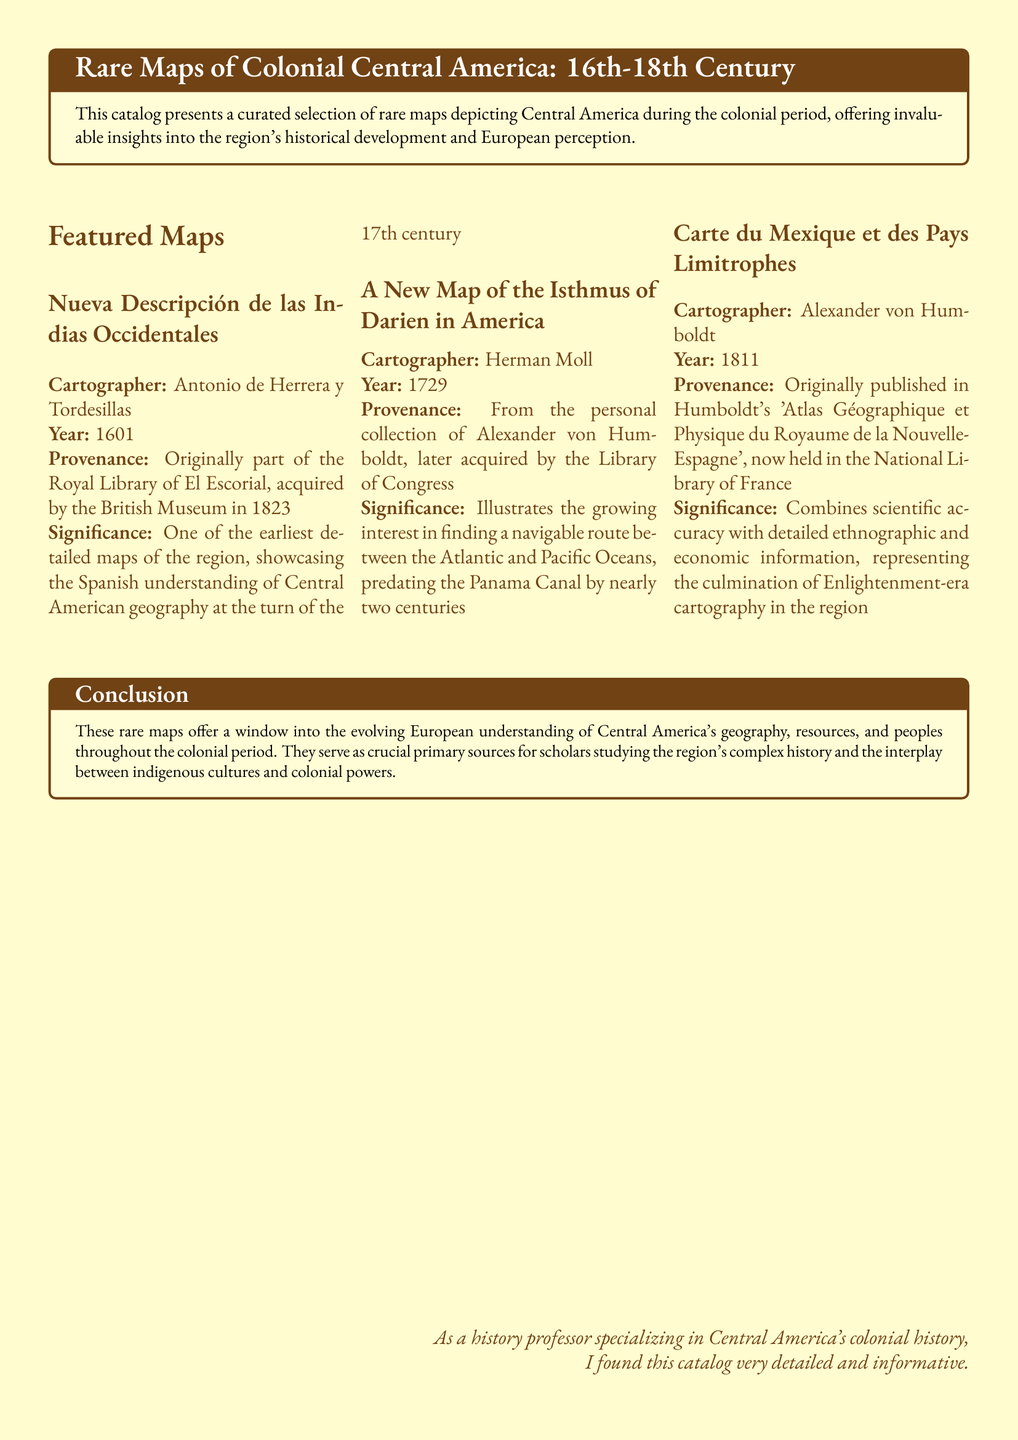What is the title of the catalog? The title is written at the beginning of the document, highlighting its focus on rare maps of the colonial period in Central America.
Answer: Rare Maps of Colonial Central America: 16th-18th Century Who is the cartographer of the 1601 map? The document provides the name of the cartographer associated with the specific map mentioned.
Answer: Antonio de Herrera y Tordesillas In what year was "A New Map of the Isthmus of Darien in America" published? The year of publication for the specific map is listed in the catalog entry.
Answer: 1729 What was the provenance of "Nueva Descripción de las Indias Occidentales"? The provenance section states the history of ownership leading to its current location.
Answer: Originally part of the Royal Library of El Escorial What is significant about "Carte du Mexique et des Pays Limitrophes"? The significance of this map is a key part of the catalog that describes its importance within the historical context.
Answer: Combines scientific accuracy with detailed ethnographic and economic information How many maps are featured in the catalog? The section titled "Featured Maps" lists the maps included in the document.
Answer: Three What type of information does the catalog provide about each map? The catalog includes specific details about each map, such as the cartographer and year, which show their historical context and significance.
Answer: Provenance information and historical context In what library is "A New Map of the Isthmus of Darien in America" currently held? The current location of this map is detailed under its provenance in the catalog.
Answer: Library of Congress 